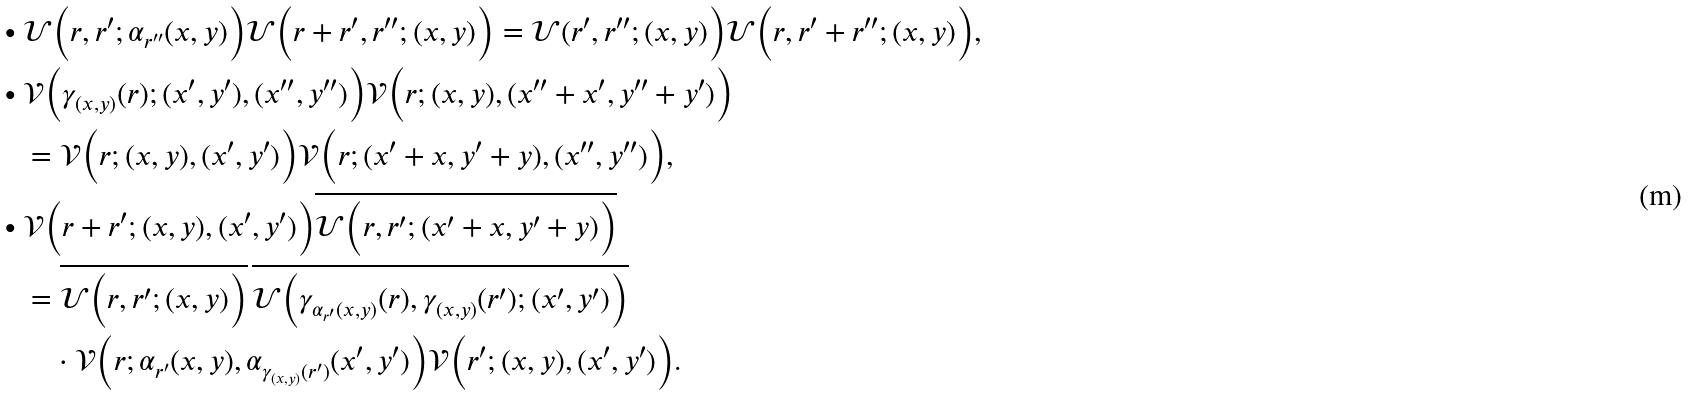Convert formula to latex. <formula><loc_0><loc_0><loc_500><loc_500>\bullet \ & { \mathcal { U } } \Big ( r , r ^ { \prime } ; \alpha _ { r ^ { \prime \prime } } ( x , y ) \Big ) { \mathcal { U } } \Big ( r + r ^ { \prime } , r ^ { \prime \prime } ; ( x , y ) \Big ) = { \mathcal { U } } ( r ^ { \prime } , r ^ { \prime \prime } ; ( x , y ) \Big ) { \mathcal { U } } \Big ( r , r ^ { \prime } + r ^ { \prime \prime } ; ( x , y ) \Big ) , \\ \bullet \ & { \mathcal { V } } \Big ( \gamma _ { ( x , y ) } ( r ) ; ( x ^ { \prime } , y ^ { \prime } ) , ( x ^ { \prime \prime } , y ^ { \prime \prime } ) \Big ) { \mathcal { V } } \Big ( r ; ( x , y ) , ( x ^ { \prime \prime } + x ^ { \prime } , y ^ { \prime \prime } + y ^ { \prime } ) \Big ) \\ & = { \mathcal { V } } \Big ( r ; ( x , y ) , ( x ^ { \prime } , y ^ { \prime } ) \Big ) { \mathcal { V } } \Big ( r ; ( x ^ { \prime } + x , y ^ { \prime } + y ) , ( x ^ { \prime \prime } , y ^ { \prime \prime } ) \Big ) , \\ \bullet \ & { \mathcal { V } } \Big ( r + r ^ { \prime } ; ( x , y ) , ( x ^ { \prime } , y ^ { \prime } ) \Big ) \overline { { \mathcal { U } } \Big ( r , r ^ { \prime } ; ( x ^ { \prime } + x , y ^ { \prime } + y ) \Big ) } \\ & = \overline { { \mathcal { U } } \Big ( r , r ^ { \prime } ; ( x , y ) \Big ) } \, \overline { { \mathcal { U } } \Big ( \gamma _ { \alpha _ { r ^ { \prime } } ( x , y ) } ( r ) , \gamma _ { ( x , y ) } ( r ^ { \prime } ) ; ( x ^ { \prime } , y ^ { \prime } ) \Big ) } \\ & \quad \cdot { \mathcal { V } } \Big ( r ; \alpha _ { r ^ { \prime } } ( x , y ) , \alpha _ { \gamma _ { ( x , y ) } ( r ^ { \prime } ) } ( x ^ { \prime } , y ^ { \prime } ) \Big ) { \mathcal { V } } \Big ( r ^ { \prime } ; ( x , y ) , ( x ^ { \prime } , y ^ { \prime } ) \Big ) .</formula> 